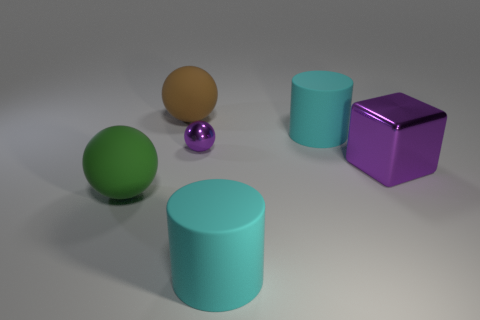Do the brown sphere and the purple metal object that is behind the metallic cube have the same size?
Give a very brief answer. No. The other matte ball that is the same size as the green ball is what color?
Provide a succinct answer. Brown. The metallic ball is what size?
Your answer should be very brief. Small. Are the large cylinder behind the tiny metal object and the large green object made of the same material?
Provide a short and direct response. Yes. Do the big green thing and the tiny metal thing have the same shape?
Your answer should be compact. Yes. The big green object that is behind the large object that is in front of the thing that is on the left side of the brown sphere is what shape?
Ensure brevity in your answer.  Sphere. Is the shape of the purple metallic thing on the left side of the large purple block the same as the object on the left side of the large brown matte ball?
Your answer should be very brief. Yes. Are there any big red objects that have the same material as the block?
Offer a terse response. No. What is the color of the metallic object that is left of the big cylinder that is on the right side of the large rubber thing that is in front of the large green rubber object?
Your answer should be very brief. Purple. Does the big cyan cylinder behind the large block have the same material as the green ball that is on the left side of the big purple cube?
Your answer should be very brief. Yes. 